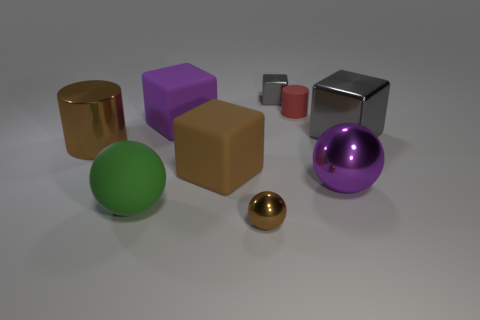There is a big metallic object that is on the left side of the brown metallic sphere; what number of matte objects are in front of it?
Your answer should be very brief. 2. There is another gray object that is the same material as the tiny gray thing; what is its shape?
Offer a very short reply. Cube. What number of gray objects are small cubes or large cylinders?
Your answer should be very brief. 1. There is a big purple object in front of the metallic cube to the right of the red rubber cylinder; are there any brown rubber objects that are on the right side of it?
Make the answer very short. No. Are there fewer yellow rubber cylinders than big green objects?
Your response must be concise. Yes. Do the large purple object that is in front of the metal cylinder and the tiny red matte object have the same shape?
Ensure brevity in your answer.  No. Are any large matte spheres visible?
Keep it short and to the point. Yes. What color is the large rubber object that is left of the big block behind the block that is right of the small gray shiny thing?
Make the answer very short. Green. Is the number of big green things that are to the right of the small gray metallic block the same as the number of small red matte cylinders behind the red rubber cylinder?
Provide a succinct answer. Yes. There is a gray object that is the same size as the red matte cylinder; what is its shape?
Give a very brief answer. Cube. 